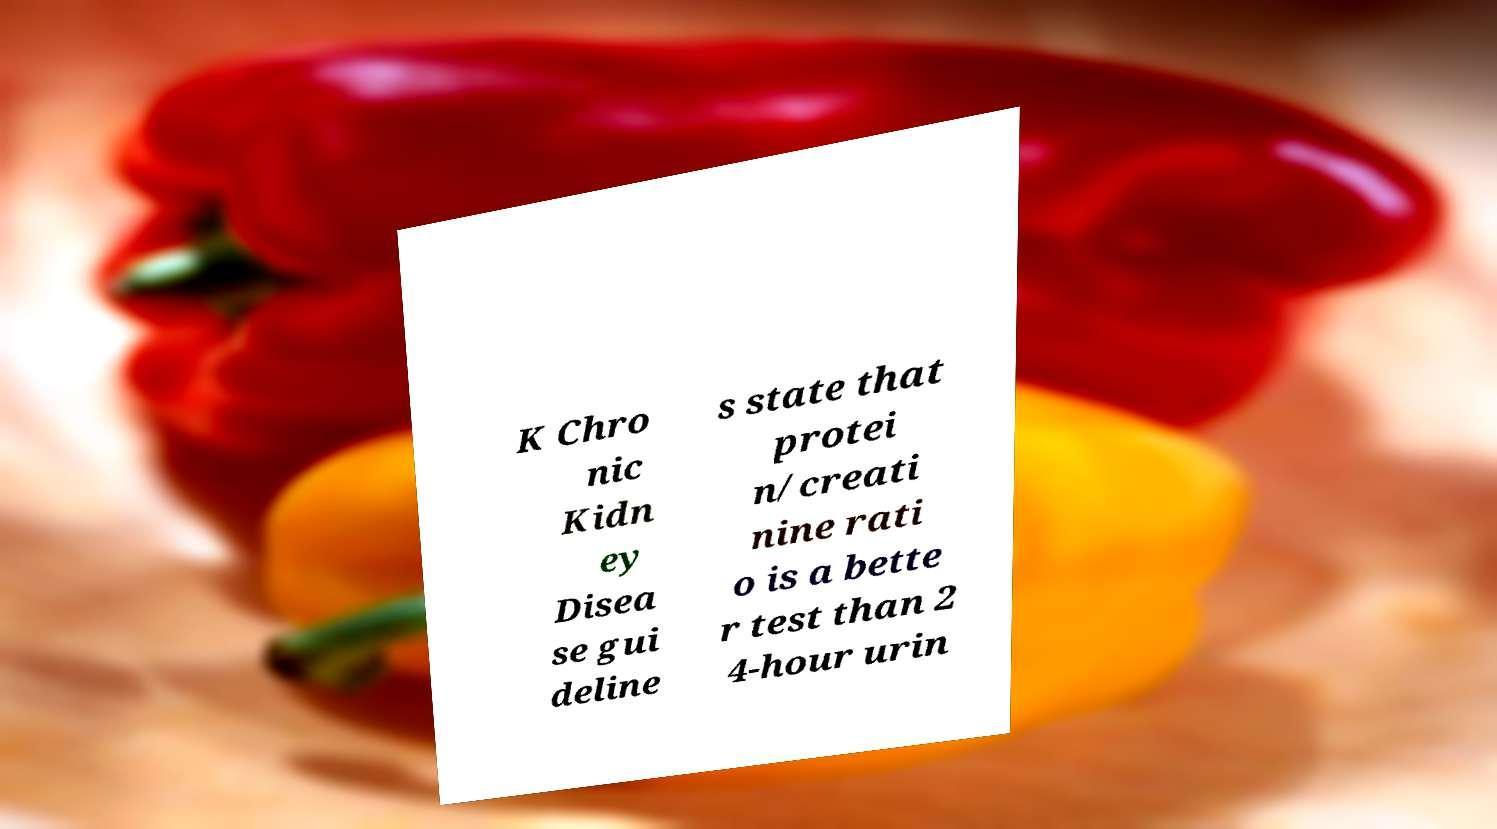What messages or text are displayed in this image? I need them in a readable, typed format. K Chro nic Kidn ey Disea se gui deline s state that protei n/creati nine rati o is a bette r test than 2 4-hour urin 